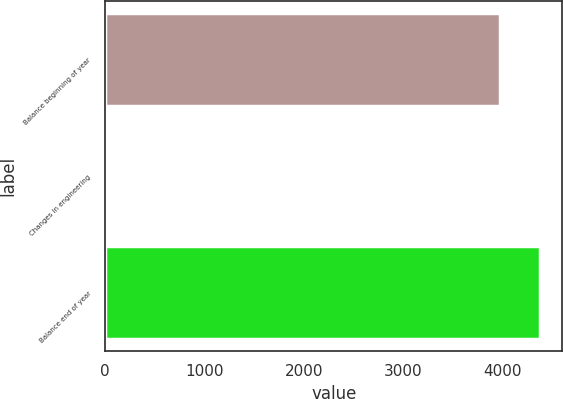Convert chart. <chart><loc_0><loc_0><loc_500><loc_500><bar_chart><fcel>Balance beginning of year<fcel>Changes in engineering<fcel>Balance end of year<nl><fcel>3979<fcel>26<fcel>4383.9<nl></chart> 